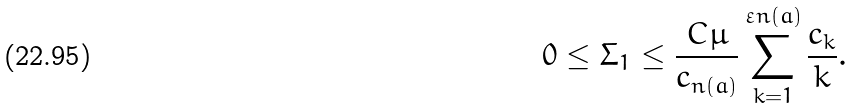Convert formula to latex. <formula><loc_0><loc_0><loc_500><loc_500>0 \leq \Sigma _ { 1 } \leq \frac { C \mu } { c _ { n ( a ) } } \sum _ { k = 1 } ^ { \varepsilon n ( a ) } \frac { c _ { k } } { k } .</formula> 